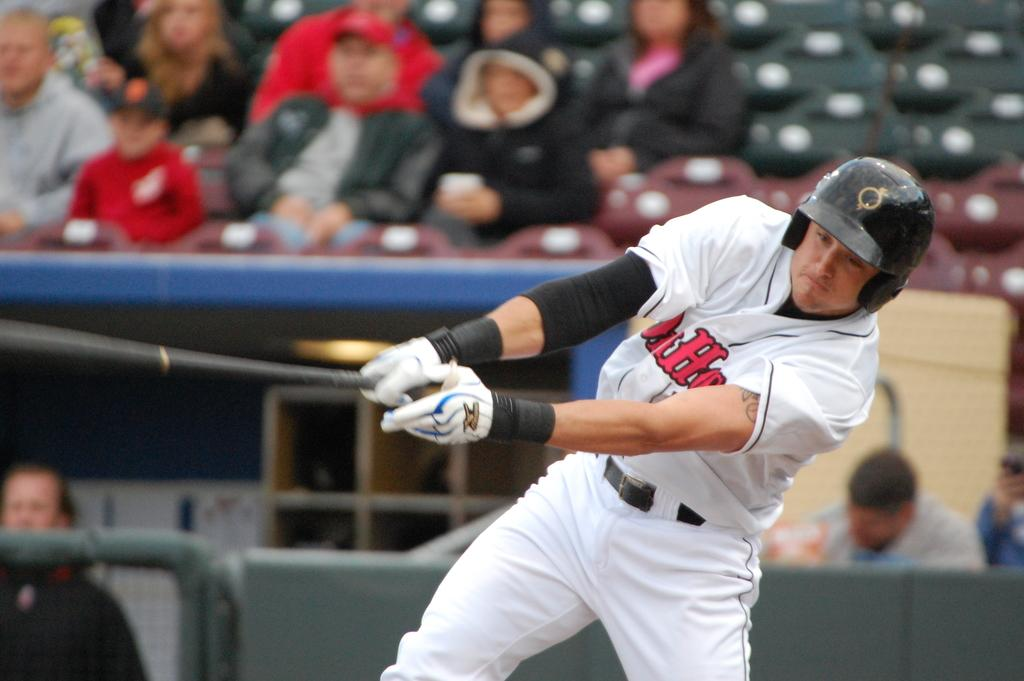<image>
Provide a brief description of the given image. A baseball player wearing the letter O on his cap swings at a pitch. 